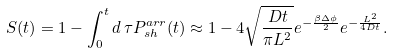Convert formula to latex. <formula><loc_0><loc_0><loc_500><loc_500>S ( t ) = 1 - \int ^ { t } _ { 0 } d \, \tau P ^ { a r r } _ { s h } ( t ) \approx 1 - 4 \sqrt { \frac { D t } { \pi L ^ { 2 } } } e ^ { - \frac { \beta \Delta \phi } 2 } e ^ { - \frac { L ^ { 2 } } { 4 D t } } .</formula> 